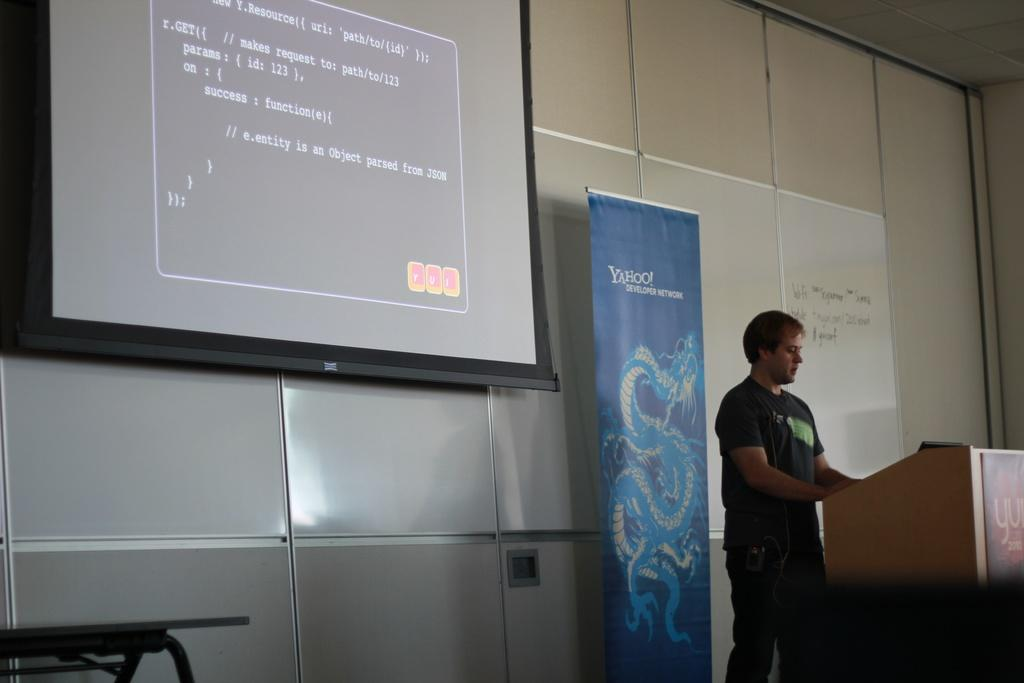<image>
Create a compact narrative representing the image presented. A technology teacher gives a lecture standing in front of a Yahoo sign while using a projector for his lesson. 